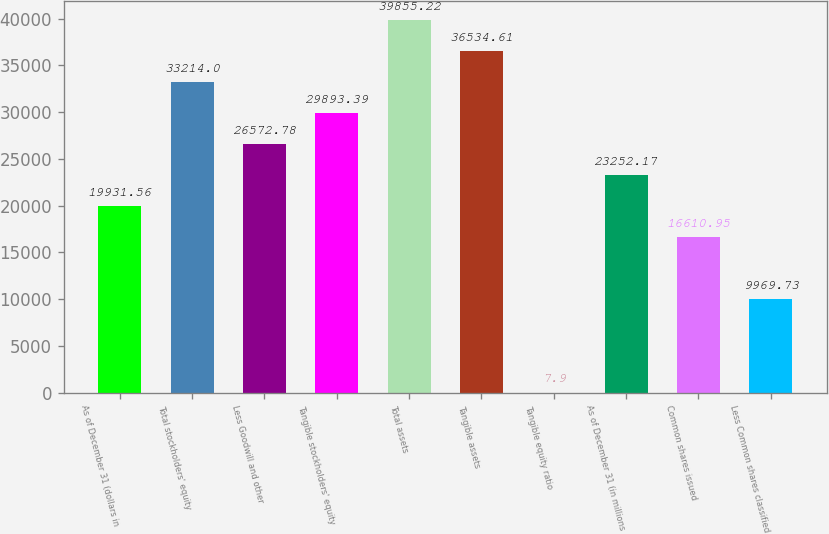Convert chart. <chart><loc_0><loc_0><loc_500><loc_500><bar_chart><fcel>As of December 31 (dollars in<fcel>Total stockholders' equity<fcel>Less Goodwill and other<fcel>Tangible stockholders' equity<fcel>Total assets<fcel>Tangible assets<fcel>Tangible equity ratio<fcel>As of December 31 (in millions<fcel>Common shares issued<fcel>Less Common shares classified<nl><fcel>19931.6<fcel>33214<fcel>26572.8<fcel>29893.4<fcel>39855.2<fcel>36534.6<fcel>7.9<fcel>23252.2<fcel>16611<fcel>9969.73<nl></chart> 